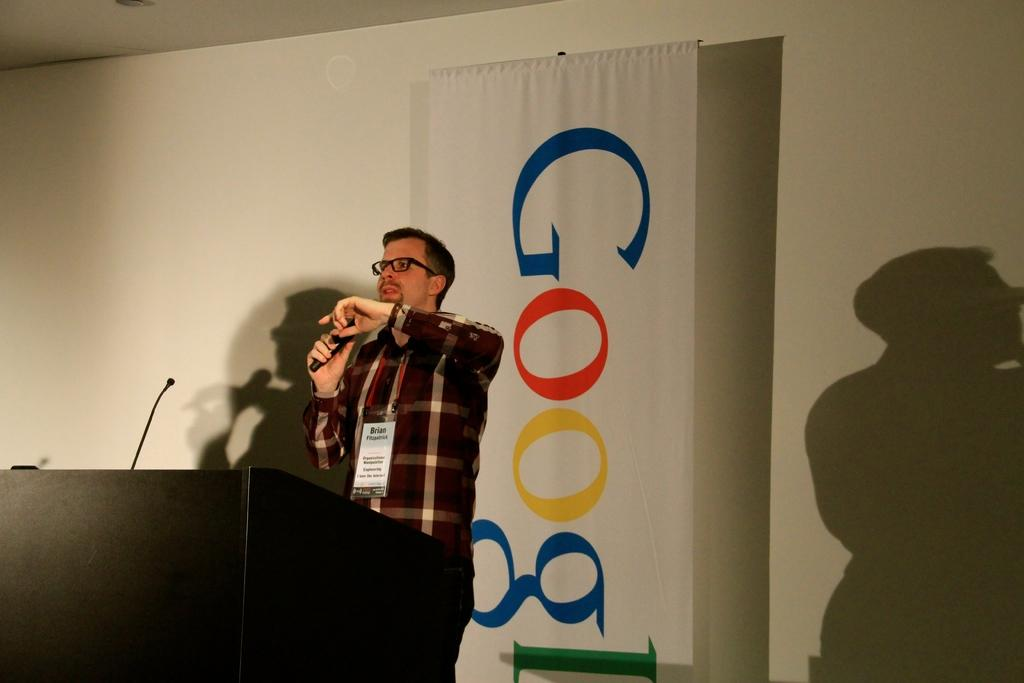Who is the main subject in the image? There is a man in the image. What is the man doing in the image? The man is standing and speaking in the image. What is the man using to amplify his voice? The man is using a microphone in the image. What is the man standing near in front of? The man is standing at a podium in the image. What is hanging on the back of the podium? There is a banner hanging on the back in the image. How many kittens are sitting on the board in the image? There are no kittens or boards present in the image. What type of yarn is the man using to knit during his speech? The man is not using any yarn in the image; he is speaking using a microphone. 